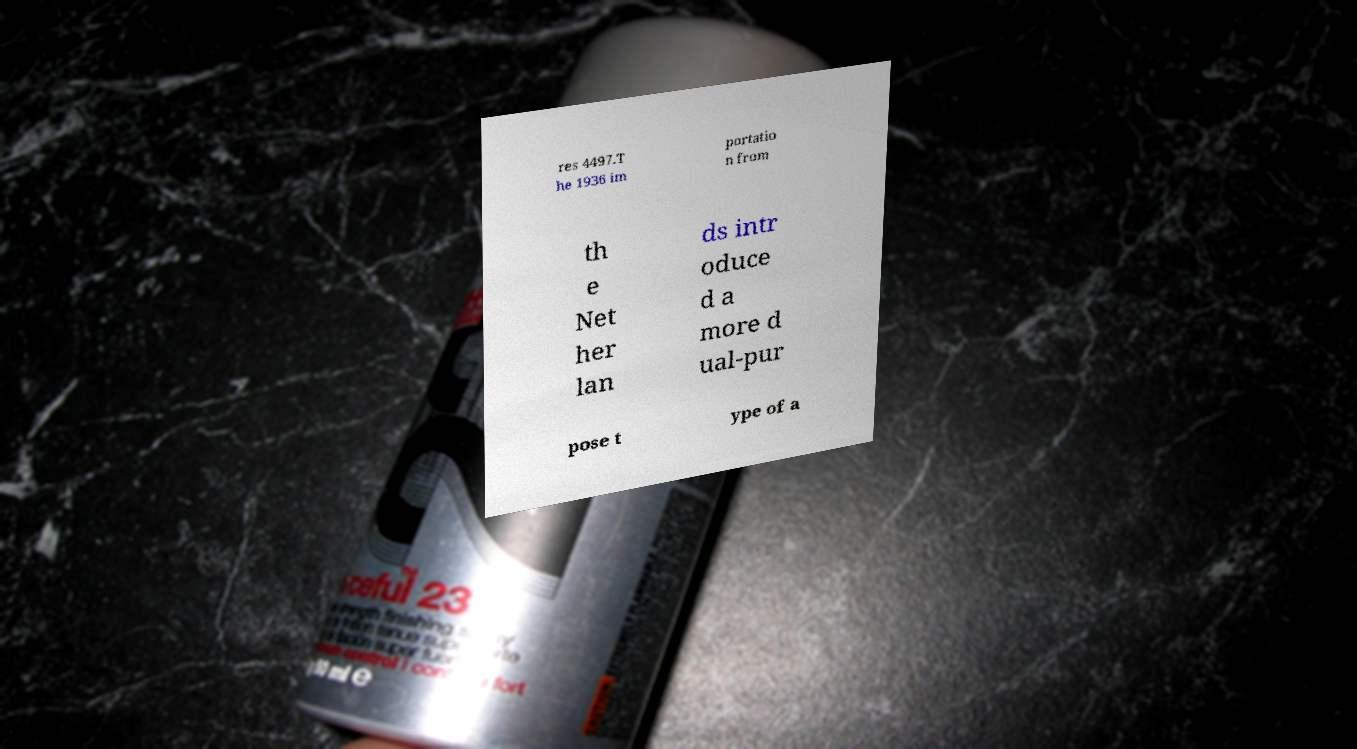There's text embedded in this image that I need extracted. Can you transcribe it verbatim? res 4497.T he 1936 im portatio n from th e Net her lan ds intr oduce d a more d ual-pur pose t ype of a 